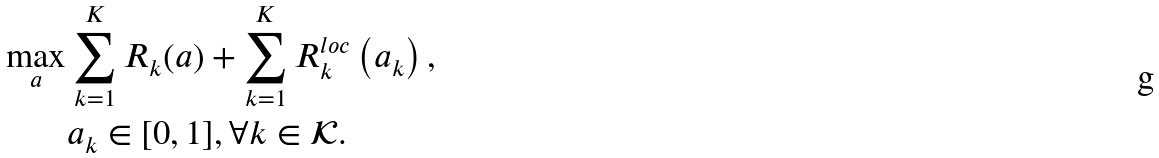<formula> <loc_0><loc_0><loc_500><loc_500>\max _ { \substack { a } } & \sum _ { k = 1 } ^ { K } R _ { k } ( a ) + \sum _ { k = 1 } ^ { K } R _ { k } ^ { l o c } \left ( a _ { k } \right ) , \\ & a _ { k } \in [ 0 , 1 ] , \forall k \in \mathcal { K } .</formula> 